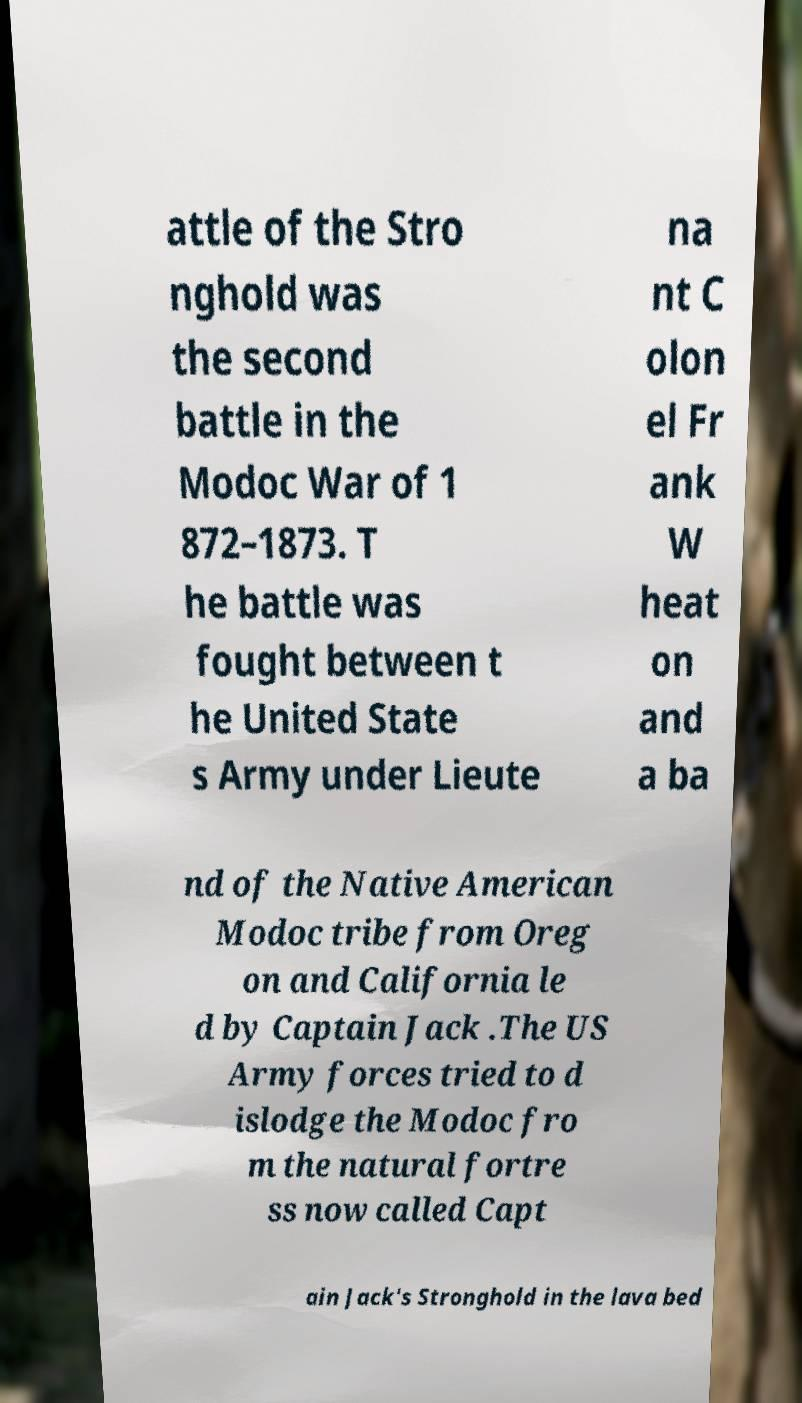Can you read and provide the text displayed in the image?This photo seems to have some interesting text. Can you extract and type it out for me? attle of the Stro nghold was the second battle in the Modoc War of 1 872–1873. T he battle was fought between t he United State s Army under Lieute na nt C olon el Fr ank W heat on and a ba nd of the Native American Modoc tribe from Oreg on and California le d by Captain Jack .The US Army forces tried to d islodge the Modoc fro m the natural fortre ss now called Capt ain Jack's Stronghold in the lava bed 